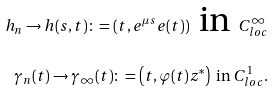Convert formula to latex. <formula><loc_0><loc_0><loc_500><loc_500>h _ { n } \rightarrow h ( s , t ) \colon = \left ( t , e ^ { \mu s } e ( t ) \right ) \text { in } C ^ { \infty } _ { l o c } \\ \gamma _ { n } ( t ) \rightarrow \gamma _ { \infty } ( t ) \colon = \left ( t , \varphi ( t ) z ^ { * } \right ) \text { in } C ^ { 1 } _ { l o c } .</formula> 